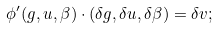Convert formula to latex. <formula><loc_0><loc_0><loc_500><loc_500>\phi ^ { \prime } ( g , u , \beta ) \cdot ( \delta g , \delta u , \delta \beta ) = \delta v ;</formula> 